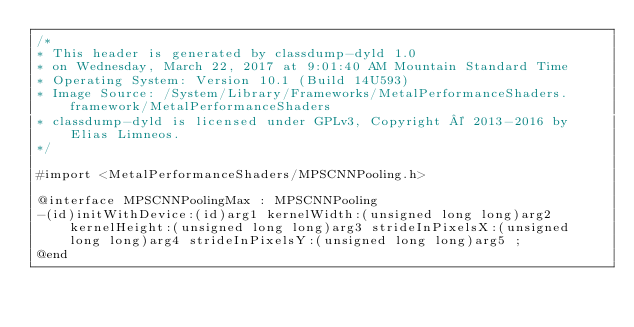<code> <loc_0><loc_0><loc_500><loc_500><_C_>/*
* This header is generated by classdump-dyld 1.0
* on Wednesday, March 22, 2017 at 9:01:40 AM Mountain Standard Time
* Operating System: Version 10.1 (Build 14U593)
* Image Source: /System/Library/Frameworks/MetalPerformanceShaders.framework/MetalPerformanceShaders
* classdump-dyld is licensed under GPLv3, Copyright © 2013-2016 by Elias Limneos.
*/

#import <MetalPerformanceShaders/MPSCNNPooling.h>

@interface MPSCNNPoolingMax : MPSCNNPooling
-(id)initWithDevice:(id)arg1 kernelWidth:(unsigned long long)arg2 kernelHeight:(unsigned long long)arg3 strideInPixelsX:(unsigned long long)arg4 strideInPixelsY:(unsigned long long)arg5 ;
@end

</code> 